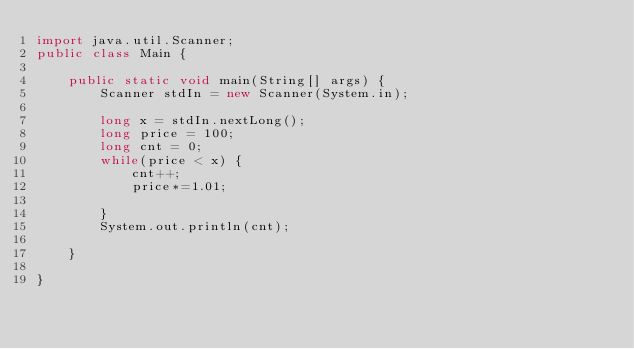Convert code to text. <code><loc_0><loc_0><loc_500><loc_500><_Java_>import java.util.Scanner;
public class Main {

	public static void main(String[] args) {
		Scanner stdIn = new Scanner(System.in);
		
		long x = stdIn.nextLong();
		long price = 100;
		long cnt = 0;
		while(price < x) {
			cnt++;
			price*=1.01;
			
		}
		System.out.println(cnt);
		
	}

}
</code> 